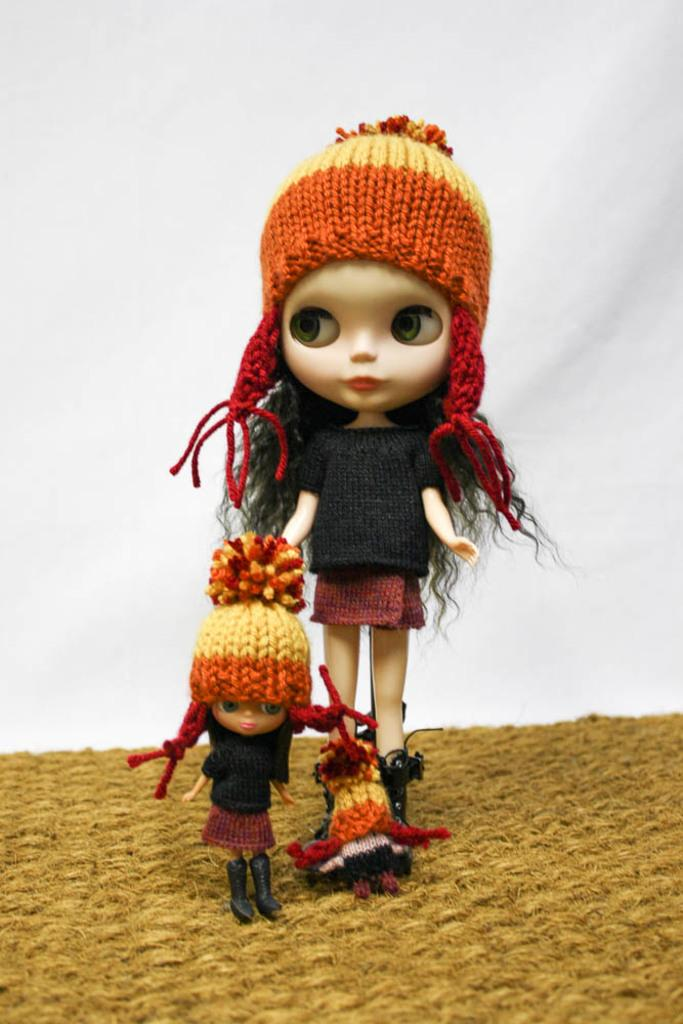What objects are present in the image? There are toys in the image. What distinguishing features do the toys have? The toys are wearing clothes, have caps, and have shoes. What color is the cloth in the image? The cloth in the image is brown in color. What is the color of the background in the image? The background of the image is white. Can you tell me how many cords are connected to the toys in the image? There are no cords connected to the toys in the image. What type of horse can be seen interacting with the toys in the image? There is no horse present in the image; it features only toys and a brown cloth. 